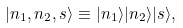<formula> <loc_0><loc_0><loc_500><loc_500>| n _ { 1 } , n _ { 2 } , s \rangle \equiv | n _ { 1 } \rangle | n _ { 2 } \rangle | s \rangle ,</formula> 